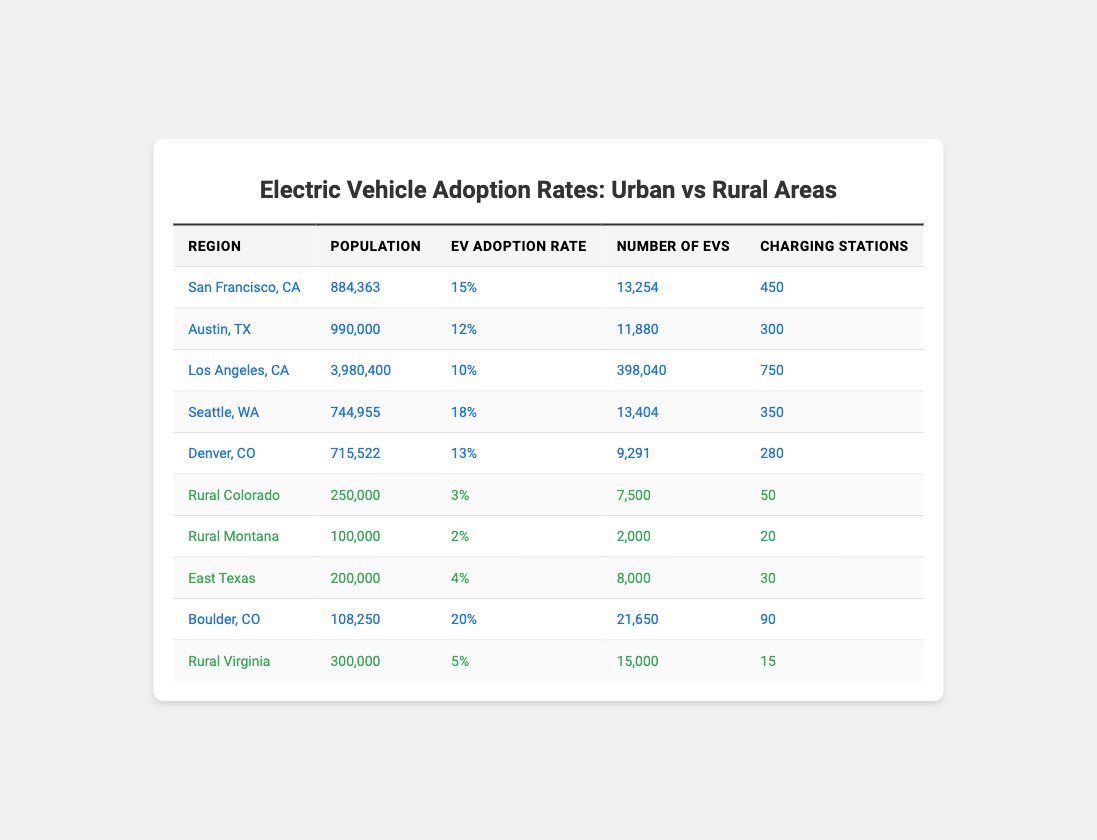What is the EV adoption rate in San Francisco, CA? According to the table, the EV adoption rate for San Francisco, CA is provided directly as 15%.
Answer: 15% Which region has the highest number of EVs? The table lists the number of EVs for each region, and upon comparing, Los Angeles, CA has 398,040 EVs, which is the most.
Answer: Los Angeles, CA How many charging stations does Rural Virginia have? The table shows that Rural Virginia has 15 charging stations listed under its row.
Answer: 15 What is the total number of EVs in rural areas? To find the total number of EVs in rural areas, we add up the Number of EVs from all rural regions: 7,500 (Rural Colorado) + 2,000 (Rural Montana) + 8,000 (East Texas) + 15,000 (Rural Virginia) = 32,500.
Answer: 32,500 What is the average EV adoption rate for urban regions? The urban regions and their EV adoption rates are San Francisco (15%), Austin (12%), Los Angeles (10%), Seattle (18%), Denver (13%), and Boulder (20%). We find the average: (15 + 12 + 10 + 18 + 13 + 20) / 6 = 98 / 6 = 16.33%.
Answer: 16.33% In which region is the EV adoption rate greater than 15%? Looking at the table, there are two regions with an EV adoption rate greater than 15%: Boulder, CO (20%) and Seattle, WA (18%).
Answer: Boulder, CO and Seattle, WA Which area has the lowest EV adoption rate? Based on the data, Rural Montana has the lowest EV adoption rate listed as 2%.
Answer: Rural Montana If we consider only rural areas, which region has the highest charging stations? From the table, we note the charging stations in the rural areas: Rural Colorado (50), Rural Montana (20), East Texas (30), and Rural Virginia (15). Thus, Rural Colorado has the highest at 50.
Answer: Rural Colorado What is the difference in EV adoption rates between urban and rural areas? The average EV adoption rate for urban areas is computed as 16.33% (previously calculated). The average rural area adoption rate is (3 + 2 + 4 + 5) / 4 = 3.5%. Therefore, the difference is 16.33% - 3.5% = 12.83%.
Answer: 12.83% Is the total urban population greater than the rural population? The total urban population is the sum of all urban populations: 884,363 (San Francisco) + 990,000 (Austin) + 3,980,400 (Los Angeles) + 744,955 (Seattle) + 715,522 (Denver) + 108,250 (Boulder) = 6,523,490. The total rural population is 250,000 (Rural Colorado) + 100,000 (Rural Montana) + 200,000 (East Texas) + 300,000 (Rural Virginia) = 850,000. Thus, 6,523,490 is indeed greater than 850,000, leading to the conclusion that it is true.
Answer: Yes What region exhibits a significant difference between the number of EVs and the number of charging stations? By analyzing the table, we can observe Boulder, CO which has 21,650 EVs and 90 charging stations, indicating a significant difference of 21,560 EVs more than charging stations.
Answer: Boulder, CO 